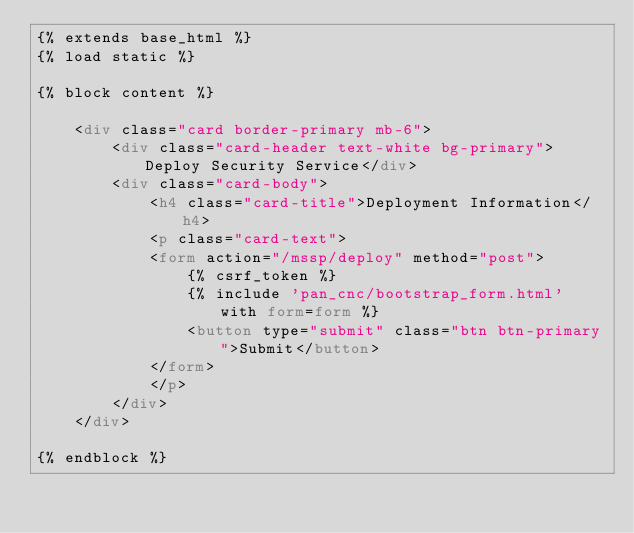<code> <loc_0><loc_0><loc_500><loc_500><_HTML_>{% extends base_html %}
{% load static %}

{% block content %}

    <div class="card border-primary mb-6">
        <div class="card-header text-white bg-primary">Deploy Security Service</div>
        <div class="card-body">
            <h4 class="card-title">Deployment Information</h4>
            <p class="card-text">
            <form action="/mssp/deploy" method="post">
                {% csrf_token %}
                {% include 'pan_cnc/bootstrap_form.html' with form=form %}
                <button type="submit" class="btn btn-primary">Submit</button>
            </form>
            </p>
        </div>
    </div>

{% endblock %}</code> 